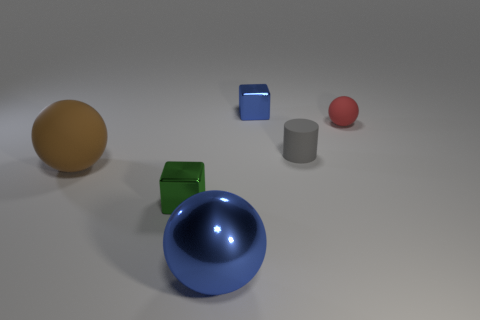Subtract all brown blocks. Subtract all cyan cylinders. How many blocks are left? 2 Subtract all brown cylinders. How many green balls are left? 0 Add 3 tiny reds. How many blues exist? 0 Subtract all small blue metallic blocks. Subtract all red objects. How many objects are left? 4 Add 3 big objects. How many big objects are left? 5 Add 1 brown cylinders. How many brown cylinders exist? 1 Add 4 large rubber spheres. How many objects exist? 10 Subtract all brown spheres. How many spheres are left? 2 Subtract all large matte spheres. How many spheres are left? 2 Subtract 1 blue cubes. How many objects are left? 5 